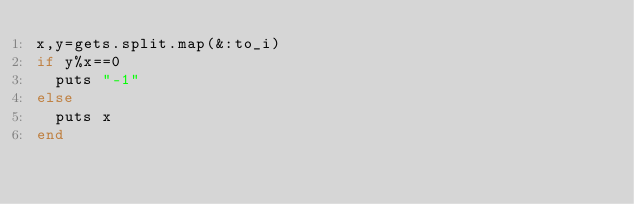Convert code to text. <code><loc_0><loc_0><loc_500><loc_500><_Ruby_>x,y=gets.split.map(&:to_i)
if y%x==0
  puts "-1"
else
  puts x
end</code> 